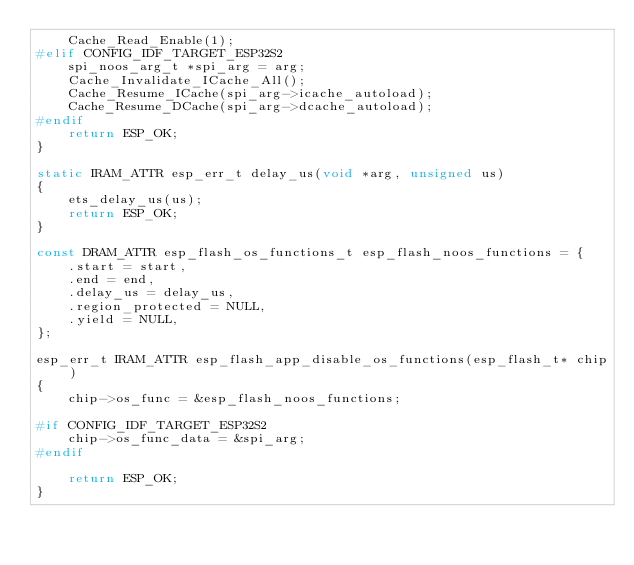<code> <loc_0><loc_0><loc_500><loc_500><_C_>    Cache_Read_Enable(1);
#elif CONFIG_IDF_TARGET_ESP32S2
    spi_noos_arg_t *spi_arg = arg;
    Cache_Invalidate_ICache_All();
    Cache_Resume_ICache(spi_arg->icache_autoload);
    Cache_Resume_DCache(spi_arg->dcache_autoload);
#endif
    return ESP_OK;
}

static IRAM_ATTR esp_err_t delay_us(void *arg, unsigned us)
{
    ets_delay_us(us);
    return ESP_OK;
}

const DRAM_ATTR esp_flash_os_functions_t esp_flash_noos_functions = {
    .start = start,
    .end = end,
    .delay_us = delay_us,
    .region_protected = NULL,
    .yield = NULL,
};

esp_err_t IRAM_ATTR esp_flash_app_disable_os_functions(esp_flash_t* chip)
{
    chip->os_func = &esp_flash_noos_functions;

#if CONFIG_IDF_TARGET_ESP32S2
    chip->os_func_data = &spi_arg;
#endif

    return ESP_OK;
}
</code> 